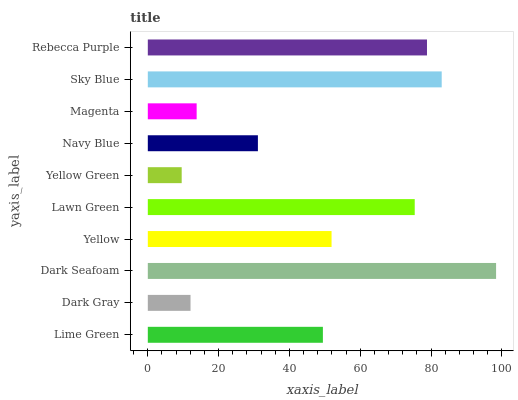Is Yellow Green the minimum?
Answer yes or no. Yes. Is Dark Seafoam the maximum?
Answer yes or no. Yes. Is Dark Gray the minimum?
Answer yes or no. No. Is Dark Gray the maximum?
Answer yes or no. No. Is Lime Green greater than Dark Gray?
Answer yes or no. Yes. Is Dark Gray less than Lime Green?
Answer yes or no. Yes. Is Dark Gray greater than Lime Green?
Answer yes or no. No. Is Lime Green less than Dark Gray?
Answer yes or no. No. Is Yellow the high median?
Answer yes or no. Yes. Is Lime Green the low median?
Answer yes or no. Yes. Is Dark Seafoam the high median?
Answer yes or no. No. Is Dark Seafoam the low median?
Answer yes or no. No. 